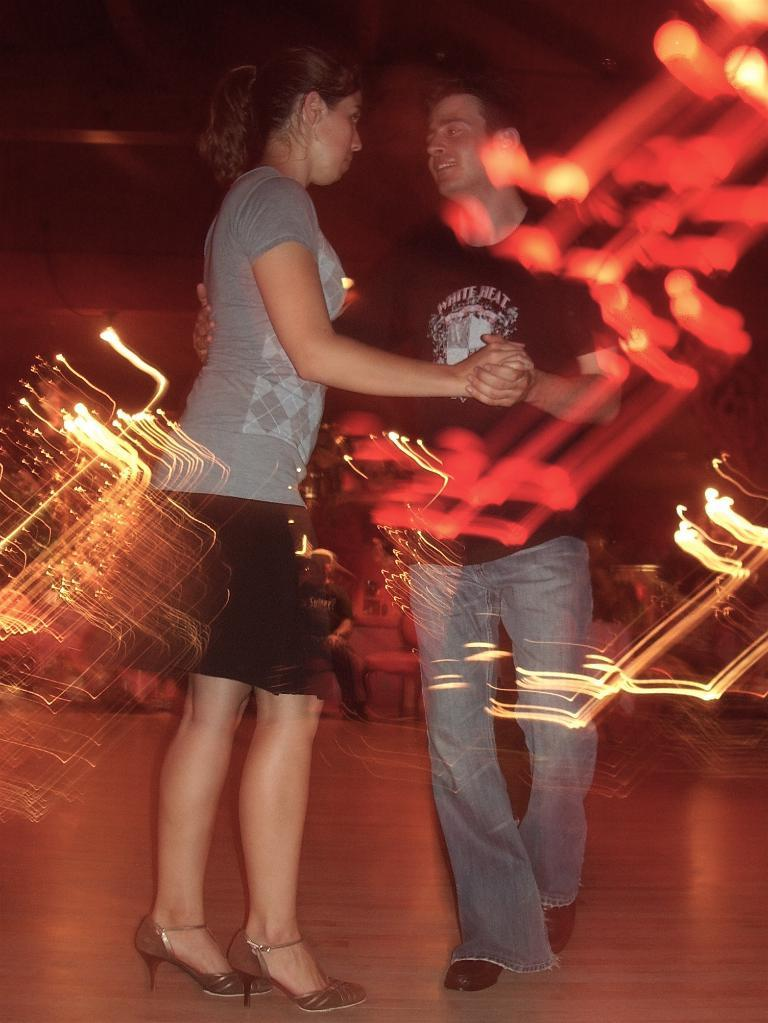What are the two people in the image doing? There is a couple dancing in the image. Where are the dancers located in the image? The couple is on the floor. Can you describe the setting of the image? There is a person sitting on a chair in the background, and there is some lighting visible in the image. What type of canvas is the couple dancing on in the image? There is no canvas present in the image; the couple is dancing on the floor. 